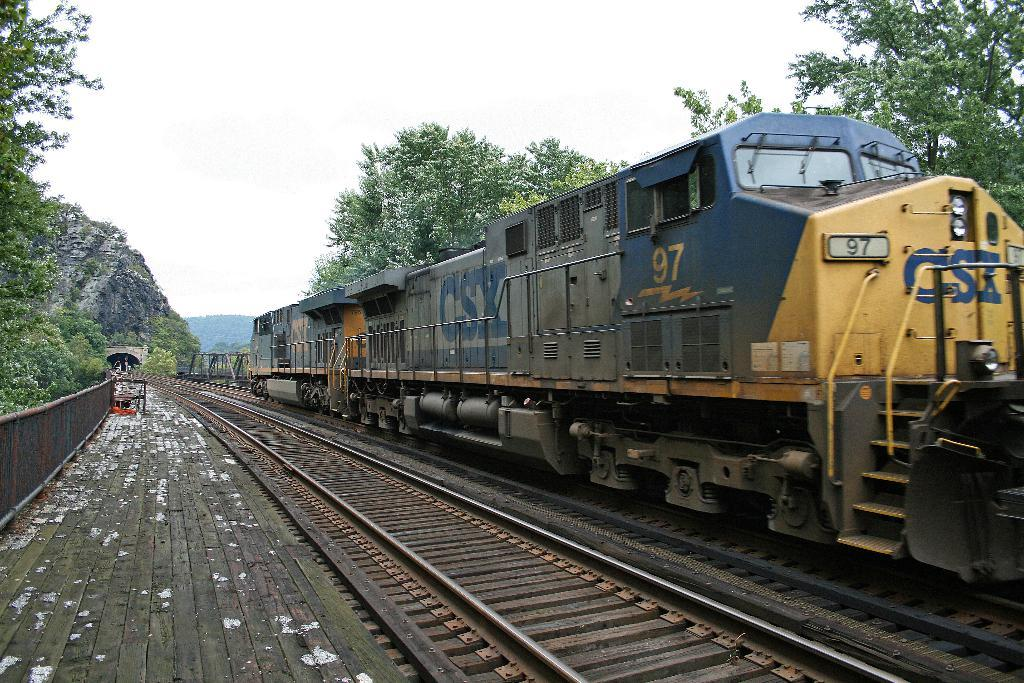What is the main subject of the image? The main subject of the image is a train. Where is the train located in the image? The train is on a railway track. What can be seen on either side of the railway track? There are trees on either side of the railway track. What is visible in the background of the image? There are mountains visible in the background. What is visible at the top of the image? The sky is visible at the top of the image. What hobbies does the train have in the image? Trains do not have hobbies, as they are inanimate objects. What type of work is the train performing in the image? The image does not provide any information about the train's purpose or function, so it is impossible to determine what type of work it might be performing. 